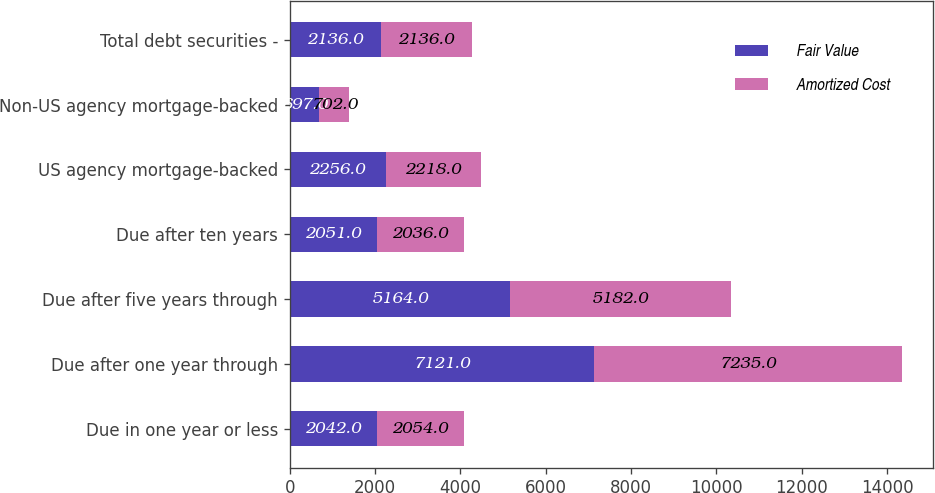Convert chart to OTSL. <chart><loc_0><loc_0><loc_500><loc_500><stacked_bar_chart><ecel><fcel>Due in one year or less<fcel>Due after one year through<fcel>Due after five years through<fcel>Due after ten years<fcel>US agency mortgage-backed<fcel>Non-US agency mortgage-backed<fcel>Total debt securities -<nl><fcel>Fair Value<fcel>2042<fcel>7121<fcel>5164<fcel>2051<fcel>2256<fcel>697<fcel>2136<nl><fcel>Amortized Cost<fcel>2054<fcel>7235<fcel>5182<fcel>2036<fcel>2218<fcel>702<fcel>2136<nl></chart> 